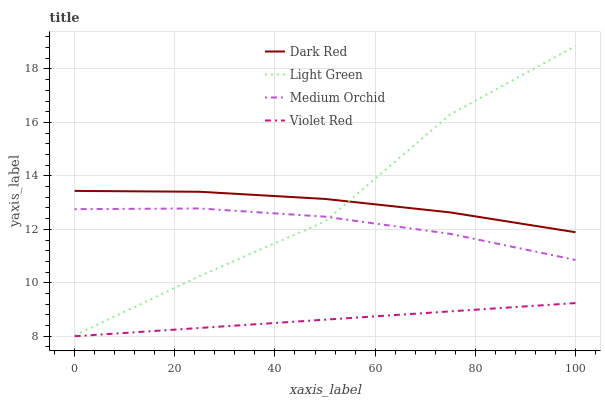Does Violet Red have the minimum area under the curve?
Answer yes or no. Yes. Does Light Green have the maximum area under the curve?
Answer yes or no. Yes. Does Medium Orchid have the minimum area under the curve?
Answer yes or no. No. Does Medium Orchid have the maximum area under the curve?
Answer yes or no. No. Is Violet Red the smoothest?
Answer yes or no. Yes. Is Light Green the roughest?
Answer yes or no. Yes. Is Medium Orchid the smoothest?
Answer yes or no. No. Is Medium Orchid the roughest?
Answer yes or no. No. Does Violet Red have the lowest value?
Answer yes or no. Yes. Does Medium Orchid have the lowest value?
Answer yes or no. No. Does Light Green have the highest value?
Answer yes or no. Yes. Does Medium Orchid have the highest value?
Answer yes or no. No. Is Medium Orchid less than Dark Red?
Answer yes or no. Yes. Is Dark Red greater than Violet Red?
Answer yes or no. Yes. Does Medium Orchid intersect Light Green?
Answer yes or no. Yes. Is Medium Orchid less than Light Green?
Answer yes or no. No. Is Medium Orchid greater than Light Green?
Answer yes or no. No. Does Medium Orchid intersect Dark Red?
Answer yes or no. No. 